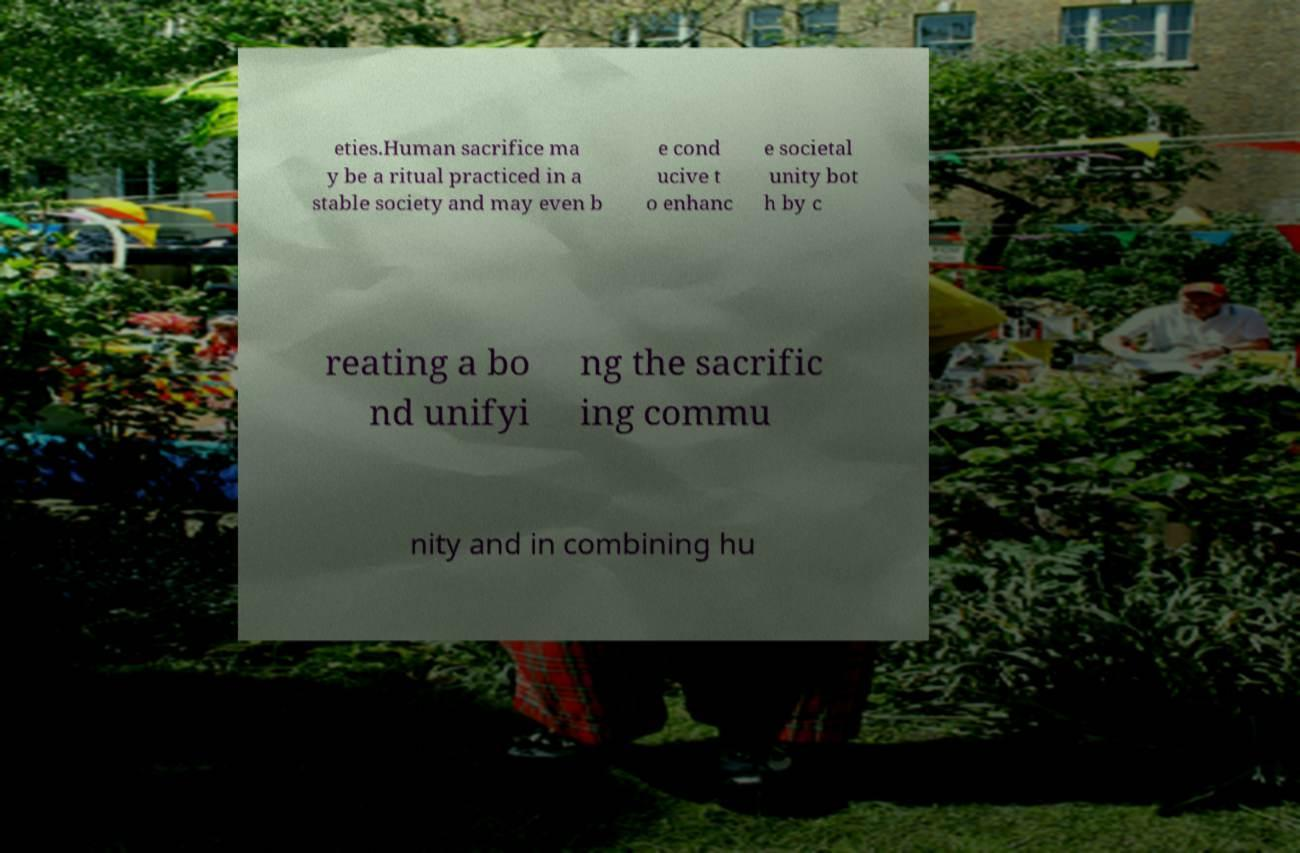Please identify and transcribe the text found in this image. eties.Human sacrifice ma y be a ritual practiced in a stable society and may even b e cond ucive t o enhanc e societal unity bot h by c reating a bo nd unifyi ng the sacrific ing commu nity and in combining hu 